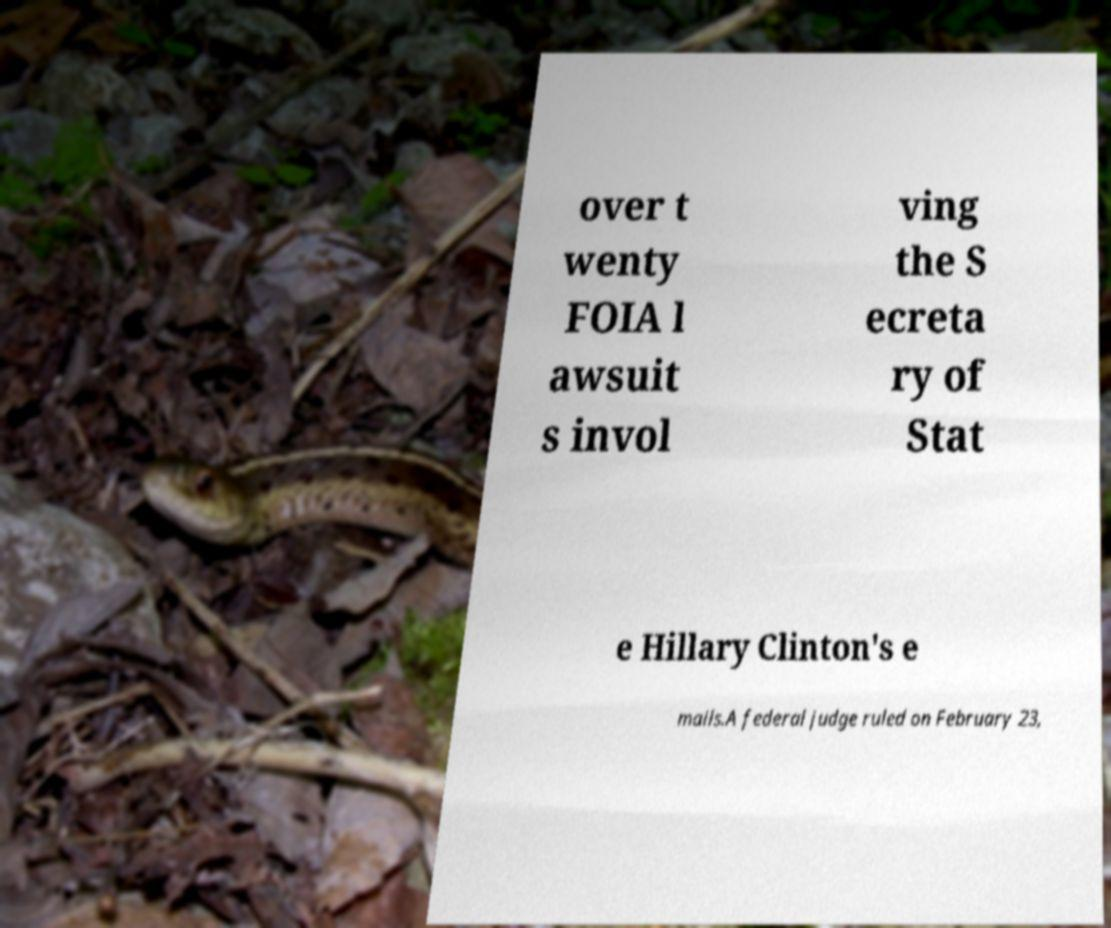Can you read and provide the text displayed in the image?This photo seems to have some interesting text. Can you extract and type it out for me? over t wenty FOIA l awsuit s invol ving the S ecreta ry of Stat e Hillary Clinton's e mails.A federal judge ruled on February 23, 